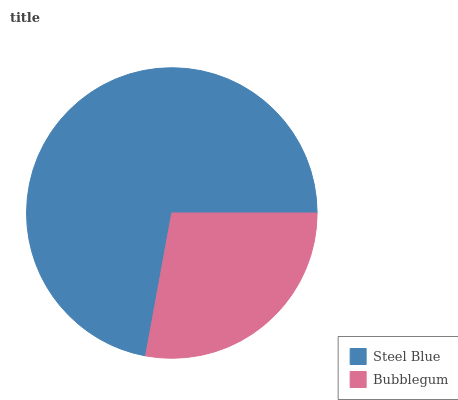Is Bubblegum the minimum?
Answer yes or no. Yes. Is Steel Blue the maximum?
Answer yes or no. Yes. Is Bubblegum the maximum?
Answer yes or no. No. Is Steel Blue greater than Bubblegum?
Answer yes or no. Yes. Is Bubblegum less than Steel Blue?
Answer yes or no. Yes. Is Bubblegum greater than Steel Blue?
Answer yes or no. No. Is Steel Blue less than Bubblegum?
Answer yes or no. No. Is Steel Blue the high median?
Answer yes or no. Yes. Is Bubblegum the low median?
Answer yes or no. Yes. Is Bubblegum the high median?
Answer yes or no. No. Is Steel Blue the low median?
Answer yes or no. No. 